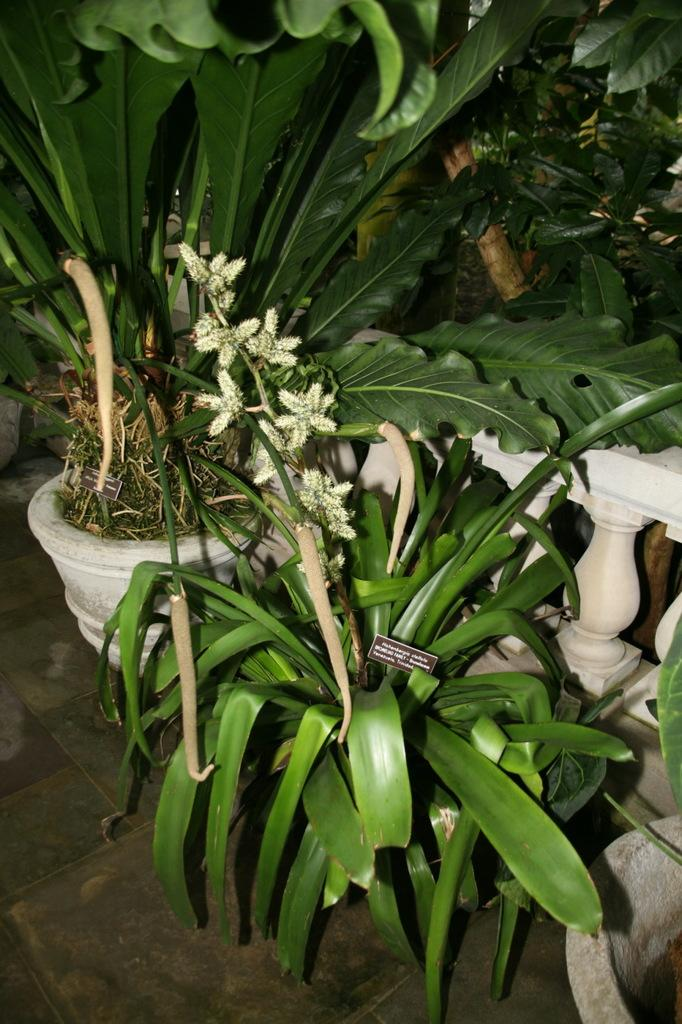What objects in the image are used for growing plants? There are plant pots in the image. What type of fence is present in the image? There is a white color fence in the image. How does the father help the plants grow in the image? There is no father present in the image, and the plants are growing in plant pots. What season is depicted in the image, considering the presence of the plants? The provided facts do not give any information about the season, as the presence of plants can be observed in various seasons. 